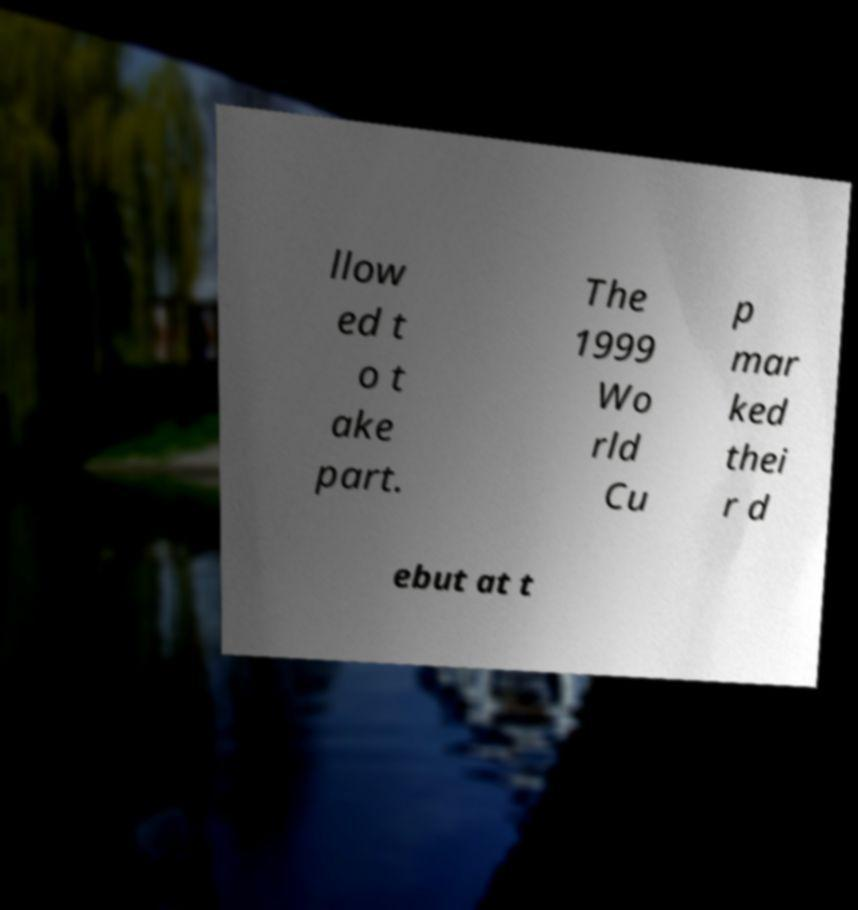What messages or text are displayed in this image? I need them in a readable, typed format. llow ed t o t ake part. The 1999 Wo rld Cu p mar ked thei r d ebut at t 